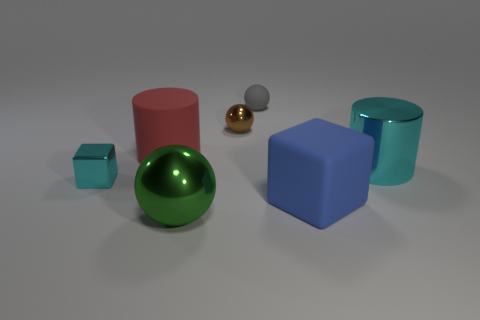Add 2 blue objects. How many objects exist? 9 Subtract all balls. How many objects are left? 4 Subtract 0 red cubes. How many objects are left? 7 Subtract all large rubber things. Subtract all tiny things. How many objects are left? 2 Add 3 tiny cyan cubes. How many tiny cyan cubes are left? 4 Add 6 large blue matte things. How many large blue matte things exist? 7 